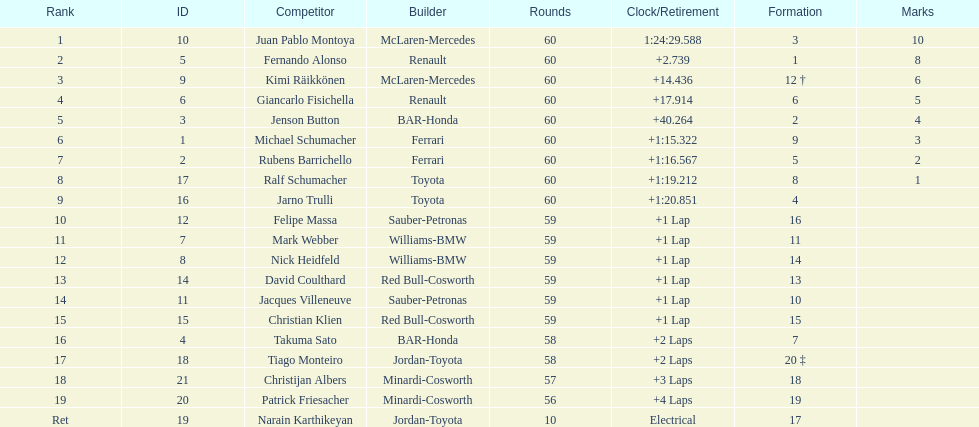Which driver has his grid at 2? Jenson Button. 